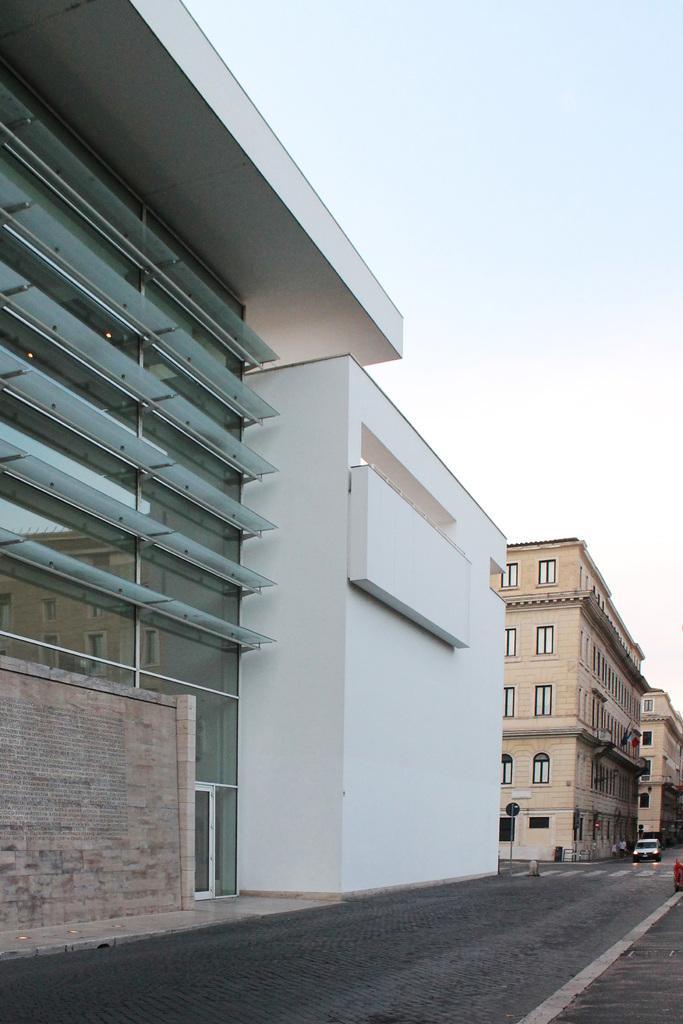In one or two sentences, can you explain what this image depicts? This picture is clicked outside. On the left we can see the buildings and the windows and walls of the buildings. In the center there is a vehicle running on the road and we can see the zebra crossings and some other objects. In the background there is a sky. 